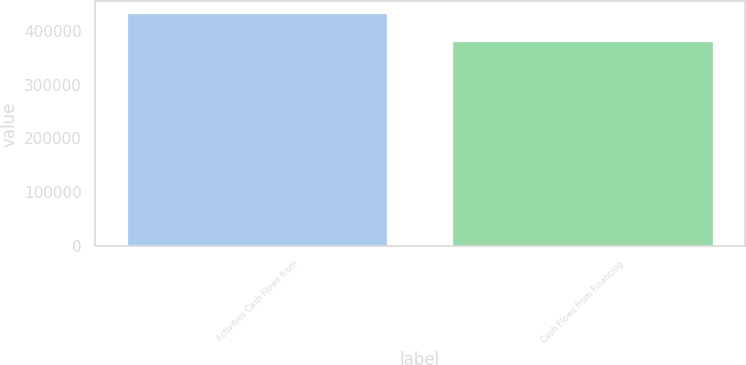<chart> <loc_0><loc_0><loc_500><loc_500><bar_chart><fcel>Activities Cash Flows from<fcel>Cash Flows from Financing<nl><fcel>432670<fcel>381234<nl></chart> 